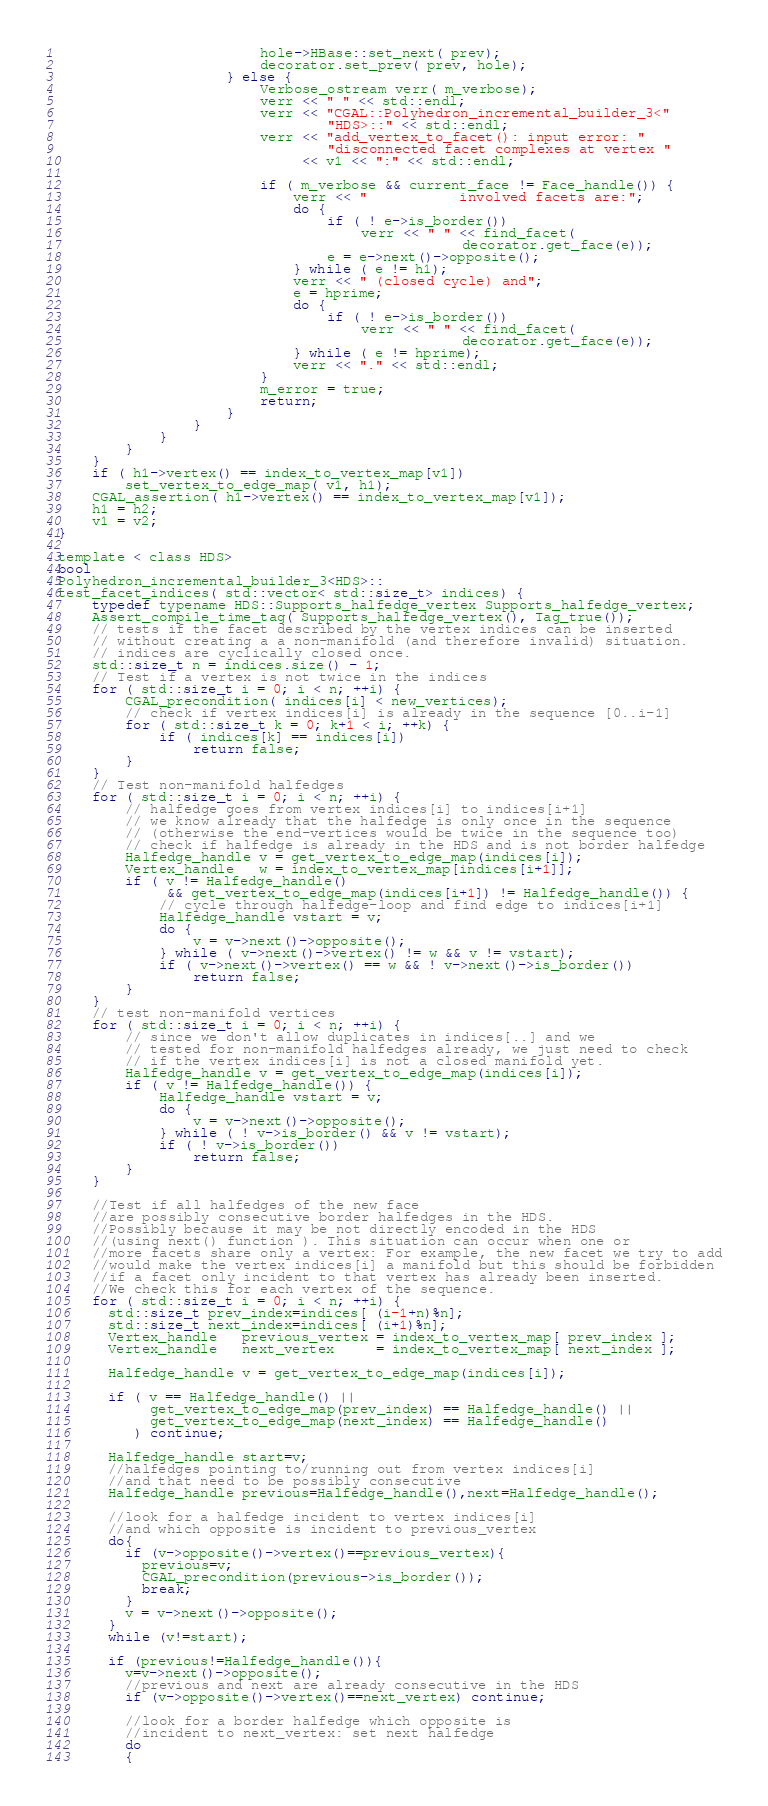<code> <loc_0><loc_0><loc_500><loc_500><_C_>                        hole->HBase::set_next( prev);
                        decorator.set_prev( prev, hole);
                    } else {
                        Verbose_ostream verr( m_verbose);
                        verr << " " << std::endl;
                        verr << "CGAL::Polyhedron_incremental_builder_3<"
                                "HDS>::" << std::endl;
                        verr << "add_vertex_to_facet(): input error: "
                                "disconnected facet complexes at vertex "
                             << v1 << ":" << std::endl;

                        if ( m_verbose && current_face != Face_handle()) {
                            verr << "           involved facets are:";
                            do {
                                if ( ! e->is_border())
                                    verr << " " << find_facet(
                                                decorator.get_face(e));
                                e = e->next()->opposite();
                            } while ( e != h1);
                            verr << " (closed cycle) and";
                            e = hprime;
                            do {
                                if ( ! e->is_border())
                                    verr << " " << find_facet(
                                                decorator.get_face(e));
                            } while ( e != hprime);
                            verr << "." << std::endl;
                        }
                        m_error = true;
                        return;
                    }
                }
            }
        }
    }
    if ( h1->vertex() == index_to_vertex_map[v1])
        set_vertex_to_edge_map( v1, h1);
    CGAL_assertion( h1->vertex() == index_to_vertex_map[v1]);
    h1 = h2;
    v1 = v2;
}

template < class HDS>
bool
Polyhedron_incremental_builder_3<HDS>::
test_facet_indices( std::vector< std::size_t> indices) {
    typedef typename HDS::Supports_halfedge_vertex Supports_halfedge_vertex;
    Assert_compile_time_tag( Supports_halfedge_vertex(), Tag_true());
    // tests if the facet described by the vertex indices can be inserted 
    // without creating a a non-manifold (and therefore invalid) situation.
    // indices are cyclically closed once.
    std::size_t n = indices.size() - 1;
    // Test if a vertex is not twice in the indices
    for ( std::size_t i = 0; i < n; ++i) {
        CGAL_precondition( indices[i] < new_vertices);
        // check if vertex indices[i] is already in the sequence [0..i-1]
        for ( std::size_t k = 0; k+1 < i; ++k) {
            if ( indices[k] == indices[i])
                return false;
        }
    }
    // Test non-manifold halfedges
    for ( std::size_t i = 0; i < n; ++i) {
        // halfedge goes from vertex indices[i] to indices[i+1]
        // we know already that the halfedge is only once in the sequence
        // (otherwise the end-vertices would be twice in the sequence too)
        // check if halfedge is already in the HDS and is not border halfedge
        Halfedge_handle v = get_vertex_to_edge_map(indices[i]);
        Vertex_handle   w = index_to_vertex_map[indices[i+1]];
        if ( v != Halfedge_handle()
             && get_vertex_to_edge_map(indices[i+1]) != Halfedge_handle()) {
            // cycle through halfedge-loop and find edge to indices[i+1]
            Halfedge_handle vstart = v;
            do {
                v = v->next()->opposite();
            } while ( v->next()->vertex() != w && v != vstart);
            if ( v->next()->vertex() == w && ! v->next()->is_border())
                return false;
        }
    }
    // test non-manifold vertices
    for ( std::size_t i = 0; i < n; ++i) {
        // since we don't allow duplicates in indices[..] and we 
        // tested for non-manifold halfedges already, we just need to check
        // if the vertex indices[i] is not a closed manifold yet.
        Halfedge_handle v = get_vertex_to_edge_map(indices[i]);
        if ( v != Halfedge_handle()) {
            Halfedge_handle vstart = v;
            do {
                v = v->next()->opposite();
            } while ( ! v->is_border() && v != vstart);
            if ( ! v->is_border())
                return false;
        }
    }
    
    //Test if all halfedges of the new face 
    //are possibly consecutive border halfedges in the HDS.
    //Possibly because it may be not directly encoded in the HDS
    //(using next() function ). This situation can occur when one or
    //more facets share only a vertex: For example, the new facet we try to add
    //would make the vertex indices[i] a manifold but this should be forbidden
    //if a facet only incident to that vertex has already been inserted.
    //We check this for each vertex of the sequence.
    for ( std::size_t i = 0; i < n; ++i) {
      std::size_t prev_index=indices[ (i-1+n)%n];
      std::size_t next_index=indices[ (i+1)%n];
      Vertex_handle   previous_vertex = index_to_vertex_map[ prev_index ];
      Vertex_handle   next_vertex     = index_to_vertex_map[ next_index ];
      
      Halfedge_handle v = get_vertex_to_edge_map(indices[i]);
      
      if ( v == Halfedge_handle() || 
           get_vertex_to_edge_map(prev_index) == Halfedge_handle() ||
           get_vertex_to_edge_map(next_index) == Halfedge_handle()
         ) continue;
      
      Halfedge_handle start=v;
      //halfedges pointing to/running out from vertex indices[i]
      //and that need to be possibly consecutive
      Halfedge_handle previous=Halfedge_handle(),next=Halfedge_handle();
      
      //look for a halfedge incident to vertex indices[i]
      //and which opposite is incident to previous_vertex
      do{
        if (v->opposite()->vertex()==previous_vertex){
          previous=v;
          CGAL_precondition(previous->is_border());
          break;
        }
        v = v->next()->opposite();
      }
      while (v!=start);
      
      if (previous!=Halfedge_handle()){
        v=v->next()->opposite();
        //previous and next are already consecutive in the HDS
        if (v->opposite()->vertex()==next_vertex) continue;
        
        //look for a border halfedge which opposite is
        //incident to next_vertex: set next halfedge
        do
        {</code> 